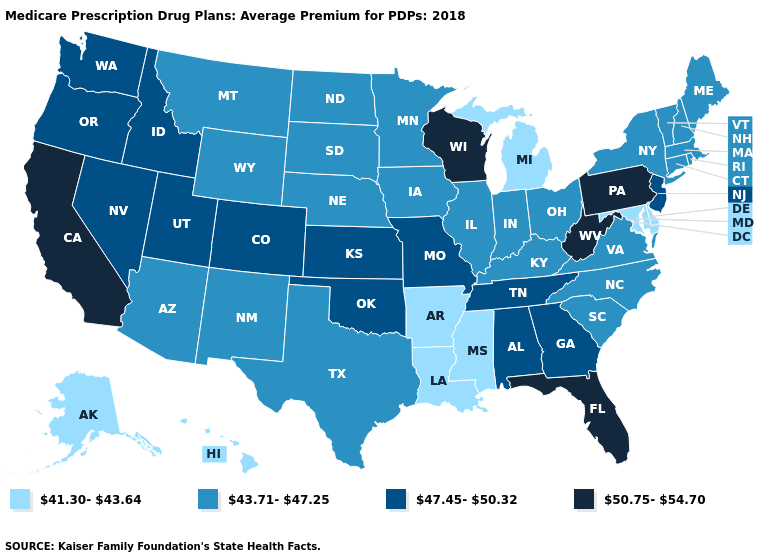Does Michigan have the lowest value in the MidWest?
Short answer required. Yes. Name the states that have a value in the range 47.45-50.32?
Write a very short answer. Alabama, Colorado, Georgia, Idaho, Kansas, Missouri, Nevada, New Jersey, Oklahoma, Oregon, Tennessee, Utah, Washington. Name the states that have a value in the range 43.71-47.25?
Quick response, please. Arizona, Connecticut, Illinois, Indiana, Iowa, Kentucky, Maine, Massachusetts, Minnesota, Montana, Nebraska, New Hampshire, New Mexico, New York, North Carolina, North Dakota, Ohio, Rhode Island, South Carolina, South Dakota, Texas, Vermont, Virginia, Wyoming. Does the first symbol in the legend represent the smallest category?
Answer briefly. Yes. What is the value of Washington?
Answer briefly. 47.45-50.32. What is the value of Ohio?
Short answer required. 43.71-47.25. What is the value of Minnesota?
Short answer required. 43.71-47.25. Name the states that have a value in the range 50.75-54.70?
Short answer required. California, Florida, Pennsylvania, West Virginia, Wisconsin. Among the states that border Alabama , does Mississippi have the highest value?
Answer briefly. No. Name the states that have a value in the range 47.45-50.32?
Write a very short answer. Alabama, Colorado, Georgia, Idaho, Kansas, Missouri, Nevada, New Jersey, Oklahoma, Oregon, Tennessee, Utah, Washington. Among the states that border Nevada , does Arizona have the lowest value?
Write a very short answer. Yes. What is the highest value in the USA?
Quick response, please. 50.75-54.70. Which states have the lowest value in the USA?
Answer briefly. Alaska, Arkansas, Delaware, Hawaii, Louisiana, Maryland, Michigan, Mississippi. What is the value of Minnesota?
Answer briefly. 43.71-47.25. Does Connecticut have the lowest value in the USA?
Be succinct. No. 